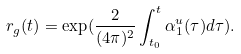<formula> <loc_0><loc_0><loc_500><loc_500>r _ { g } ( t ) = \exp ( \frac { 2 } { ( 4 \pi ) ^ { 2 } } \int _ { t _ { 0 } } ^ { t } \alpha _ { 1 } ^ { u } ( \tau ) d \tau ) .</formula> 